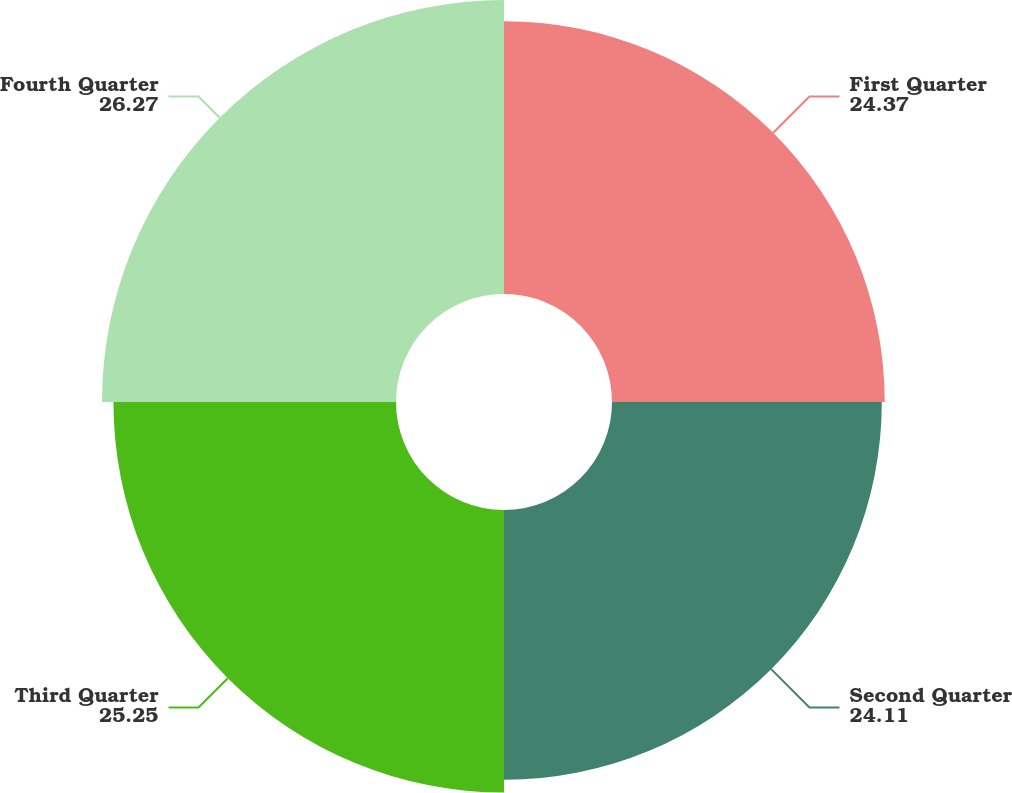<chart> <loc_0><loc_0><loc_500><loc_500><pie_chart><fcel>First Quarter<fcel>Second Quarter<fcel>Third Quarter<fcel>Fourth Quarter<nl><fcel>24.37%<fcel>24.11%<fcel>25.25%<fcel>26.27%<nl></chart> 